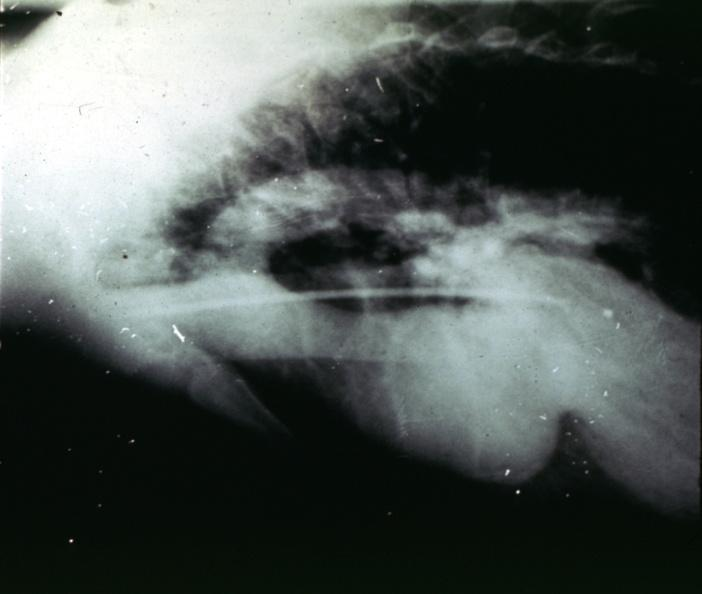s this image shows of smooth muscle cell with lipid in sarcoplasm and lipid present?
Answer the question using a single word or phrase. No 